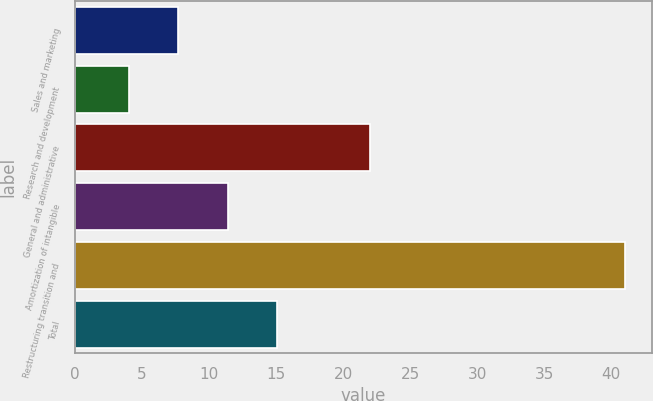Convert chart. <chart><loc_0><loc_0><loc_500><loc_500><bar_chart><fcel>Sales and marketing<fcel>Research and development<fcel>General and administrative<fcel>Amortization of intangible<fcel>Restructuring transition and<fcel>Total<nl><fcel>7.7<fcel>4<fcel>22<fcel>11.4<fcel>41<fcel>15.1<nl></chart> 